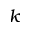<formula> <loc_0><loc_0><loc_500><loc_500>k</formula> 